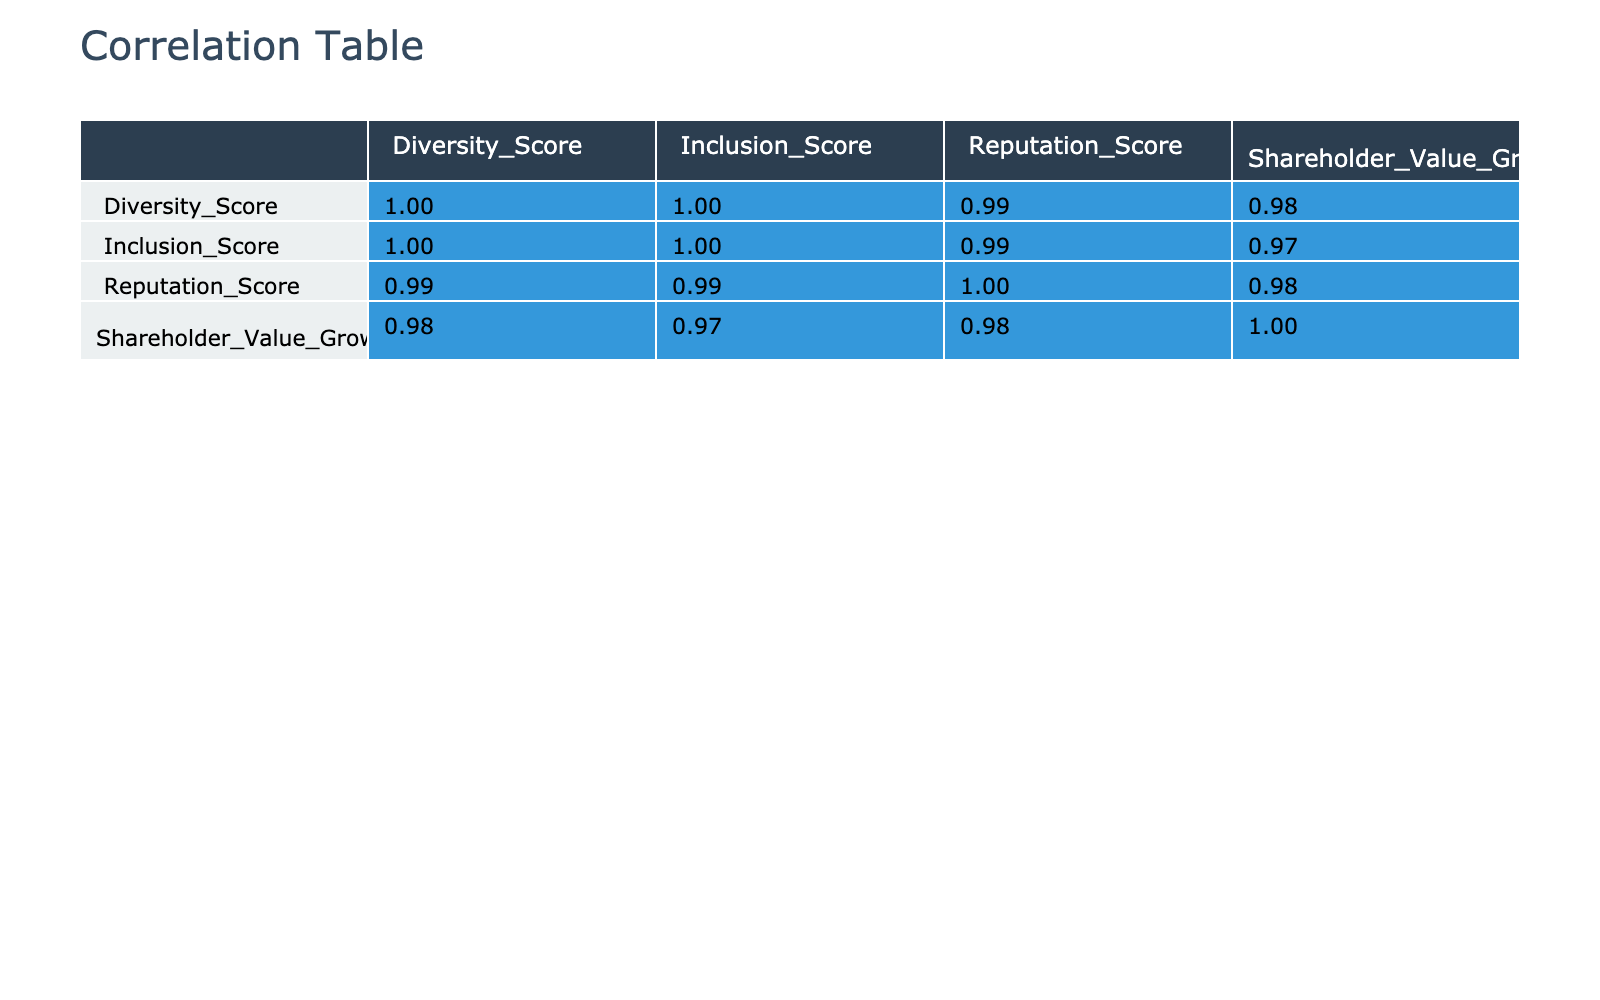What is the Diversity Score of Company C? The table shows that Company C has a Diversity Score of 90.
Answer: 90 Which company has the highest Reputation Score? Looking at the Reputation Score column, Company G has the highest score of 9.5.
Answer: Company G What is the difference between the highest and lowest Shareholder Value Growth? The highest Shareholder Value Growth is 18.0 (Company G) and the lowest is 5.0 (Company D). The difference is 18.0 - 5.0 = 13.0.
Answer: 13.0 Is Company A's Inclusion Score higher than Company J's? Company A has an Inclusion Score of 90, while Company J has a score of 74. Since 90 is greater than 74, the answer is yes.
Answer: Yes What is the average Reputation Score of all companies? To calculate the average, first sum all the Reputation Scores: 8.5 + 7.0 + 9.0 + 6.5 + 7.5 + 8.0 + 9.5 + 6.8 + 7.8 + 7.2 = 78.0. There are 10 companies, so the average is 78.0 / 10 = 7.8.
Answer: 7.8 Which company shows the most significant positive correlation between Diversity Score and Shareholder Value Growth? To find the most significant correlation, I would look for the highest positive correlation value between the Diversity Score and Shareholder Value Growth in the table. This analysis indicates that Company G, with a Diversity Score of 95, also has the highest Shareholder Value Growth of 18.0.
Answer: Company G Is it true that lower Diversity Scores correlate with lower Reputation Scores? By assessing the table, Companies D and H, which have the lowest Diversity Scores (60 and 65, respectively), also have lower Reputation Scores (6.5 and 6.8). Thus, yes, it appears there is a correlation suggesting lower Diversity correlates with lower Reputation.
Answer: Yes What is the median Inclusion Score among all companies? To find the median, first list the Inclusion Scores in ascending order: 65, 70, 74, 75, 80, 82, 85, 90, 90, 95. The median is the average of the 5th and 6th values in this ordered list: (80 + 82) / 2 = 81.
Answer: 81 Does Company E have a higher Shareholder Value Growth compared to Company D? Company E has a Shareholder Value Growth of 10.0, while Company D has only 5.0. Since 10.0 is greater than 5.0, the answer is yes.
Answer: Yes 